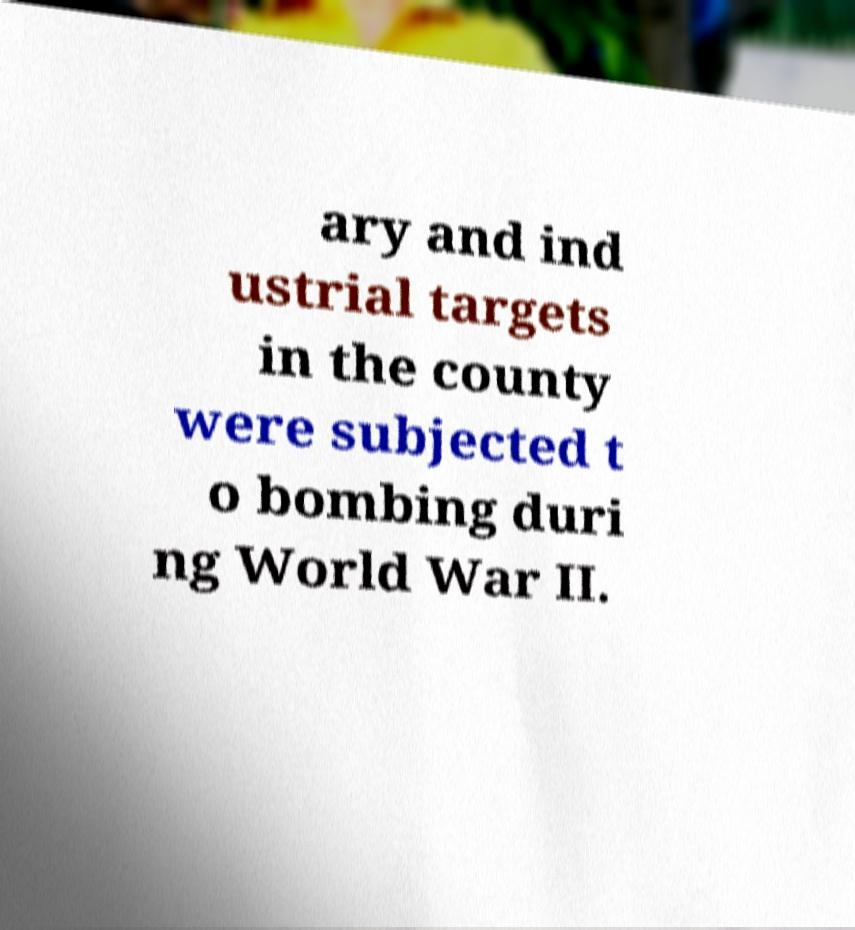Please identify and transcribe the text found in this image. ary and ind ustrial targets in the county were subjected t o bombing duri ng World War II. 